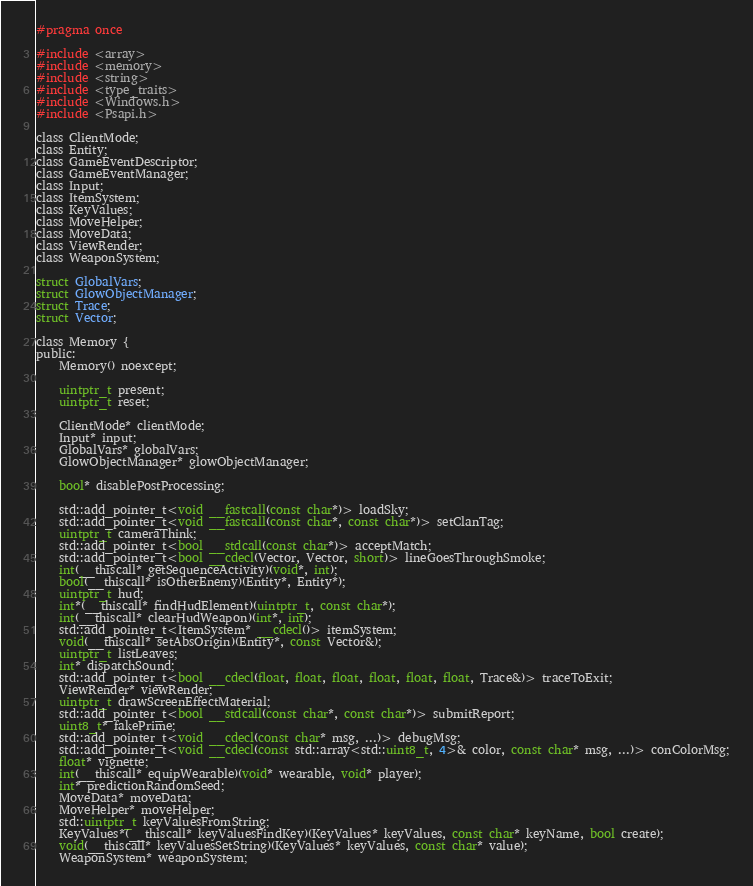Convert code to text. <code><loc_0><loc_0><loc_500><loc_500><_C_>#pragma once

#include <array>
#include <memory>
#include <string>
#include <type_traits>
#include <Windows.h>
#include <Psapi.h>

class ClientMode;
class Entity;
class GameEventDescriptor;
class GameEventManager;
class Input;
class ItemSystem;
class KeyValues;
class MoveHelper;
class MoveData;
class ViewRender;
class WeaponSystem;

struct GlobalVars;
struct GlowObjectManager;
struct Trace;
struct Vector;

class Memory {
public:
    Memory() noexcept;

    uintptr_t present;
    uintptr_t reset;

    ClientMode* clientMode;
    Input* input;
    GlobalVars* globalVars;
    GlowObjectManager* glowObjectManager;

    bool* disablePostProcessing;

    std::add_pointer_t<void __fastcall(const char*)> loadSky;
    std::add_pointer_t<void __fastcall(const char*, const char*)> setClanTag;
    uintptr_t cameraThink;
    std::add_pointer_t<bool __stdcall(const char*)> acceptMatch;
    std::add_pointer_t<bool __cdecl(Vector, Vector, short)> lineGoesThroughSmoke;
    int(__thiscall* getSequenceActivity)(void*, int);
    bool(__thiscall* isOtherEnemy)(Entity*, Entity*);
    uintptr_t hud;
    int*(__thiscall* findHudElement)(uintptr_t, const char*);
    int(__thiscall* clearHudWeapon)(int*, int);
    std::add_pointer_t<ItemSystem* __cdecl()> itemSystem;
    void(__thiscall* setAbsOrigin)(Entity*, const Vector&);
    uintptr_t listLeaves;
    int* dispatchSound;
    std::add_pointer_t<bool __cdecl(float, float, float, float, float, float, Trace&)> traceToExit;
    ViewRender* viewRender;
    uintptr_t drawScreenEffectMaterial;
    std::add_pointer_t<bool __stdcall(const char*, const char*)> submitReport;
    uint8_t* fakePrime;
    std::add_pointer_t<void __cdecl(const char* msg, ...)> debugMsg;
    std::add_pointer_t<void __cdecl(const std::array<std::uint8_t, 4>& color, const char* msg, ...)> conColorMsg;
    float* vignette;
    int(__thiscall* equipWearable)(void* wearable, void* player);
    int* predictionRandomSeed;
    MoveData* moveData;
    MoveHelper* moveHelper;
    std::uintptr_t keyValuesFromString;
    KeyValues*(__thiscall* keyValuesFindKey)(KeyValues* keyValues, const char* keyName, bool create);
    void(__thiscall* keyValuesSetString)(KeyValues* keyValues, const char* value);
    WeaponSystem* weaponSystem;</code> 